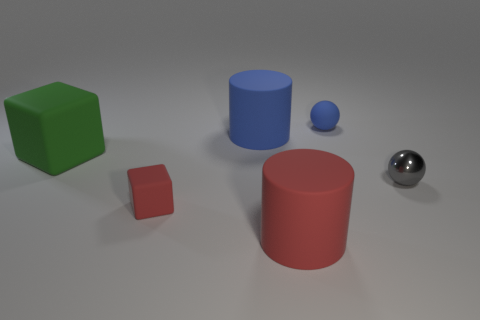The red thing that is the same size as the green block is what shape?
Make the answer very short. Cylinder. Do the large rubber object that is in front of the small gray sphere and the small rubber thing that is on the right side of the tiny red thing have the same shape?
Give a very brief answer. No. There is a object that is the same color as the small cube; what material is it?
Offer a very short reply. Rubber. What is the size of the red object that is the same shape as the large green rubber object?
Your answer should be compact. Small. What number of other objects are there of the same color as the small rubber cube?
Keep it short and to the point. 1. What number of blocks are rubber things or small cyan things?
Keep it short and to the point. 2. There is a thing on the right side of the tiny object behind the small gray thing; what color is it?
Your response must be concise. Gray. What is the shape of the tiny red thing?
Offer a terse response. Cube. Do the rubber cylinder that is left of the red rubber cylinder and the tiny metal ball have the same size?
Make the answer very short. No. Are there any small purple objects made of the same material as the tiny gray thing?
Offer a very short reply. No. 